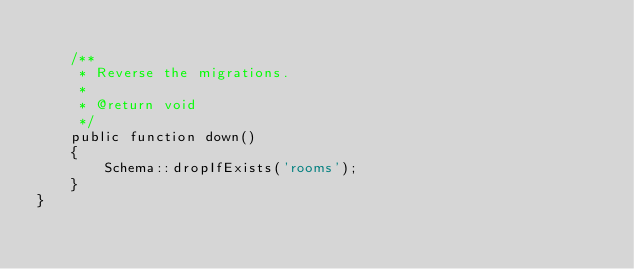Convert code to text. <code><loc_0><loc_0><loc_500><loc_500><_PHP_>
    /**
     * Reverse the migrations.
     *
     * @return void
     */
    public function down()
    {
        Schema::dropIfExists('rooms');
    }
}
</code> 